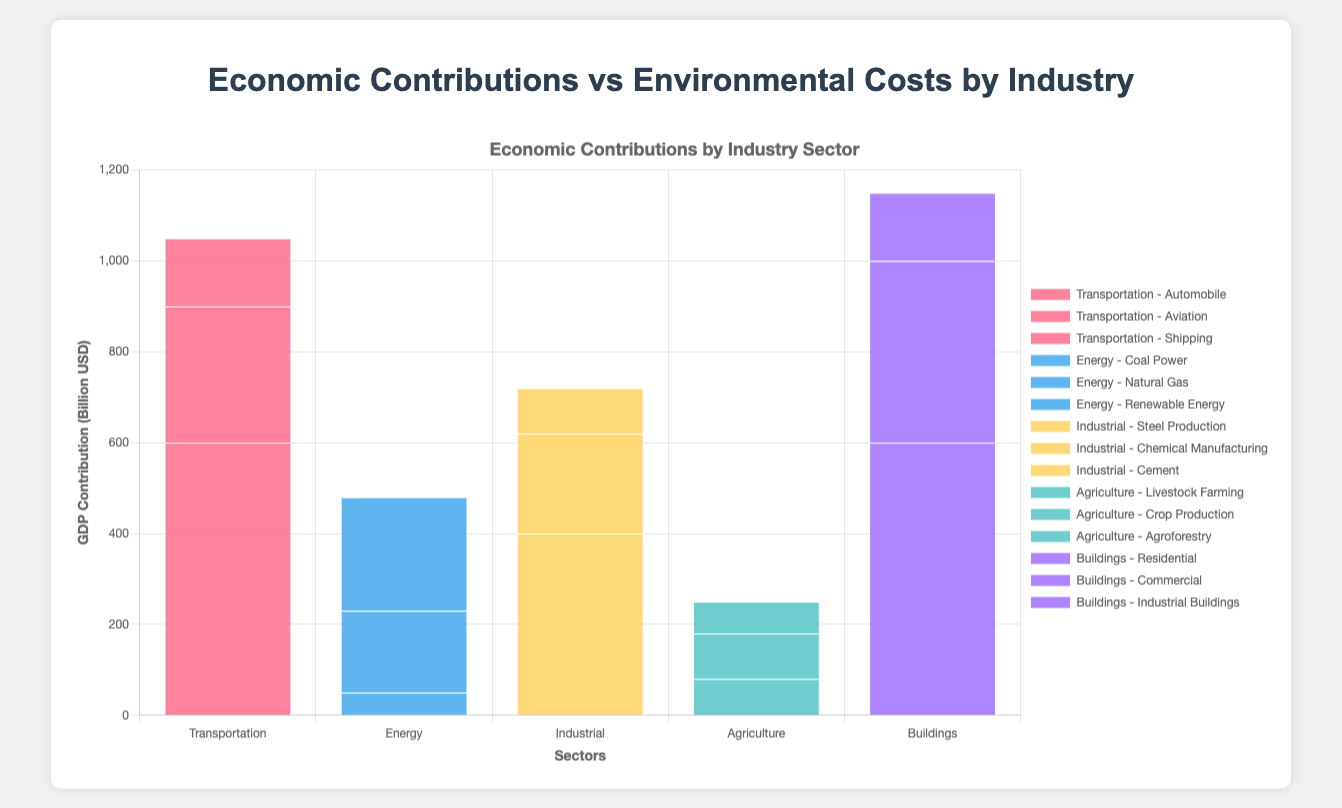Which sector has the highest overall GDP contribution? By observing the stacked bars, the sector with the highest overall height in the GDP axis will have the highest GDP contribution. "Transportation" has the highest sum as the bar is the tallest.
Answer: Transportation How do emissions from "Steel Production" compare to GDP contributions from "Residential Buildings"? "Steel Production" has emissions of 5000 mtCO2e, whereas "Residential Buildings" contribute 600 billion USD to GDP. Observing each sector, "Steel Production" emissions visually surpass the economic contribution of "Residential Buildings."
Answer: Steel Production emissions are higher Which industry within the "Energy" sector has the lowest GDP contribution and what is it? Each section of the "Energy" bar represents an industry. By comparing the stack heights in relation to the GDP axis, "Coal Power" shows the smallest height, indicating the lowest GDP contribution of 50 billion USD.
Answer: Coal Power, 50 billion USD What is the summed GDP contribution of the "Commercial" and "Residential" buildings industries? To find the summed GDP contribution, add the heights representing "Commercial" (400 billion USD) and "Residential" (600 billion USD) on the GDP axis. The total is 1000 billion USD.
Answer: 1000 billion USD Which industry in "Transportation" has the highest emissions and what is it? The red segments within "Transportation" indicate the emissions for each industry. The "Automobile" segment is visually the tallest, showing it has the highest emissions at 3200 mtCO2e.
Answer: Automobile, 3200 mtCO2e How does the GDP contribution of "Renewable Energy" compare to "Steel Production"? "Renewable Energy" shows a GDP contribution of 250 billion USD and "Steel Production" has a contribution of 400 billion USD. The height of the "Steel Production" segment is taller than "Renewable Energy's".
Answer: Steel Production contributes more Which sector has the largest emissions and what industry contributes the most to these emissions? The tallest bar segment in terms of emissions is in the "Energy" sector. Within "Energy," the highest emissions come from "Coal Power" at 7000 mtCO2e.
Answer: Energy, Coal Power What is the total emissions of "Chemical Manufacturing" and "Cement"? Adding emissions from "Chemical Manufacturing" (1800 mtCO2e) and "Cement" (3600 mtCO2e) gives a total emission of 5400 mtCO2e.
Answer: 5400 mtCO2e Visualize the emission levels corresponding to more than 3000 mtCO2e within each sector. Which industries stand out? Stacked bars higher than the 3000 mtCO2e mark indicate that "Automobile," "Coal Power," "Steel Production," "Cement," and "Livestock Farming" are prominent in emissions.
Answer: Automobile, Coal Power, Steel Production, Cement, Livestock Farming Compare the number of industries with emissions greater than 1000 mtCO2e in the "Industrial" and "Buildings" sectors. Which sector has more? In "Industrial," "Steel Production" (5000 mtCO2e) and "Cement" (3600 mtCO2e) are above 1000 mtCO2e. In "Buildings," only "Residential" (1100 mtCO2e) is above this threshold. Thus, "Industrial" has more industries above 1000 mtCO2e.
Answer: Industrial 